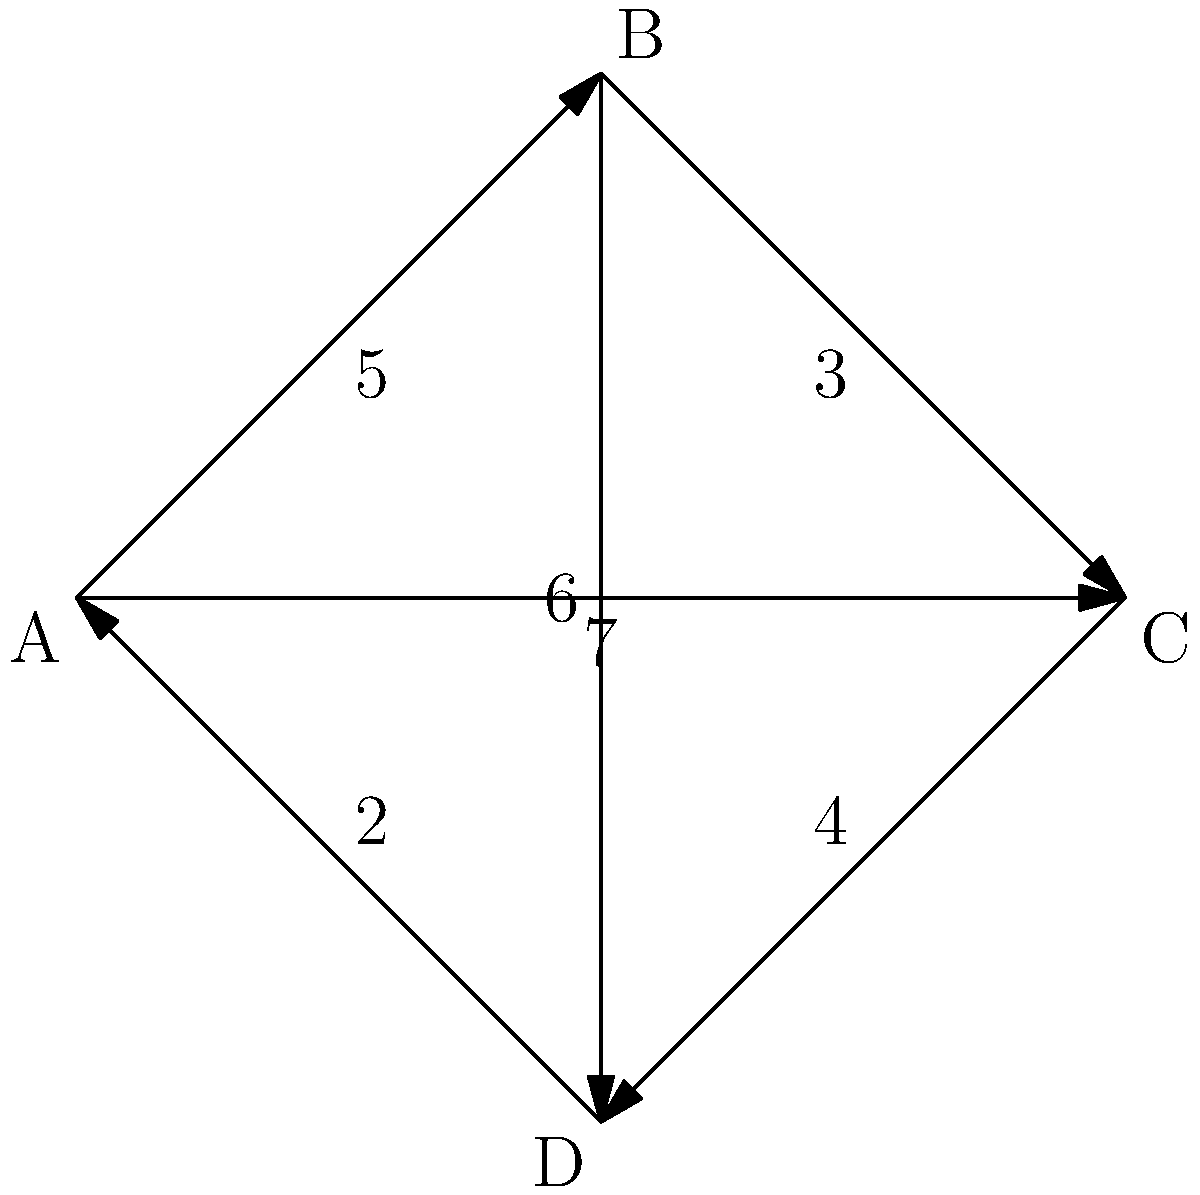As a locomotive engineer, you need to determine the most efficient route for distributing cargo between four stations (A, B, C, and D) represented in the weighted graph. Each edge represents a train route, and the weight indicates the time (in hours) required to travel between stations. What is the minimum total time required to visit all stations, starting and ending at station A, while visiting each station exactly once? To solve this problem, we need to find the shortest Hamiltonian cycle in the given weighted graph. This is known as the Traveling Salesman Problem (TSP). For a small graph like this, we can use a brute-force approach:

1. List all possible Hamiltonian cycles starting and ending at A:
   - A → B → C → D → A
   - A → B → D → C → A
   - A → C → B → D → A
   - A → C → D → B → A
   - A → D → B → C → A
   - A → D → C → B → A

2. Calculate the total time for each cycle:
   - A → B → C → D → A: 5 + 3 + 4 + 2 = 14 hours
   - A → B → D → C → A: 5 + 6 + 4 + 7 = 22 hours
   - A → C → B → D → A: 7 + 3 + 6 + 2 = 18 hours
   - A → C → D → B → A: 7 + 4 + 6 + 5 = 22 hours
   - A → D → B → C → A: 2 + 6 + 3 + 7 = 18 hours
   - A → D → C → B → A: 2 + 4 + 3 + 5 = 14 hours

3. Identify the cycle(s) with the minimum total time:
   Two cycles have the minimum time of 14 hours:
   - A → B → C → D → A
   - A → D → C → B → A

Therefore, the minimum total time required to visit all stations, starting and ending at station A, while visiting each station exactly once is 14 hours.
Answer: 14 hours 